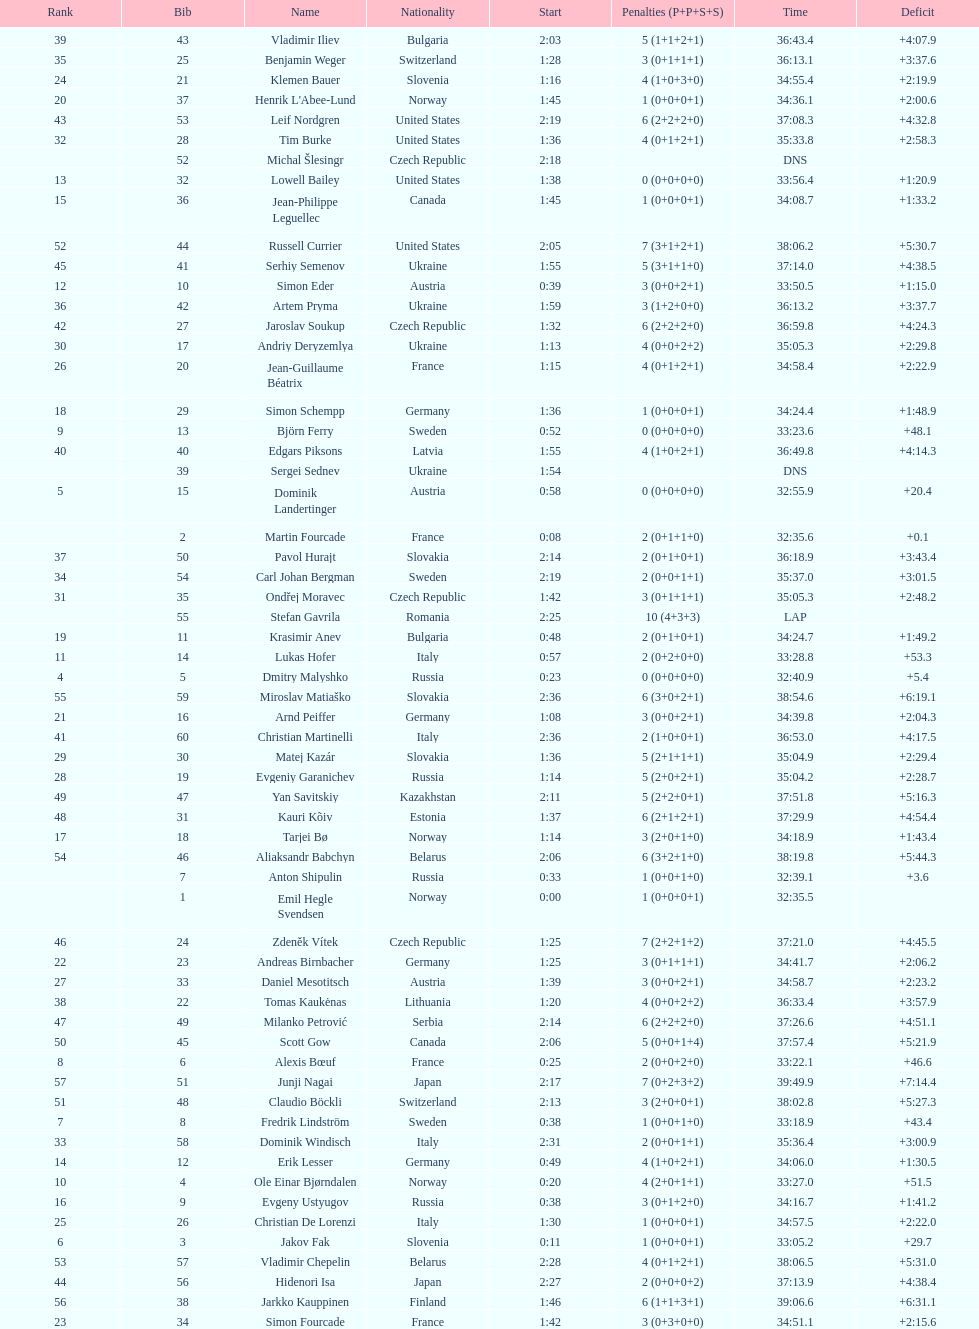How many united states competitors did not win medals? 4. 